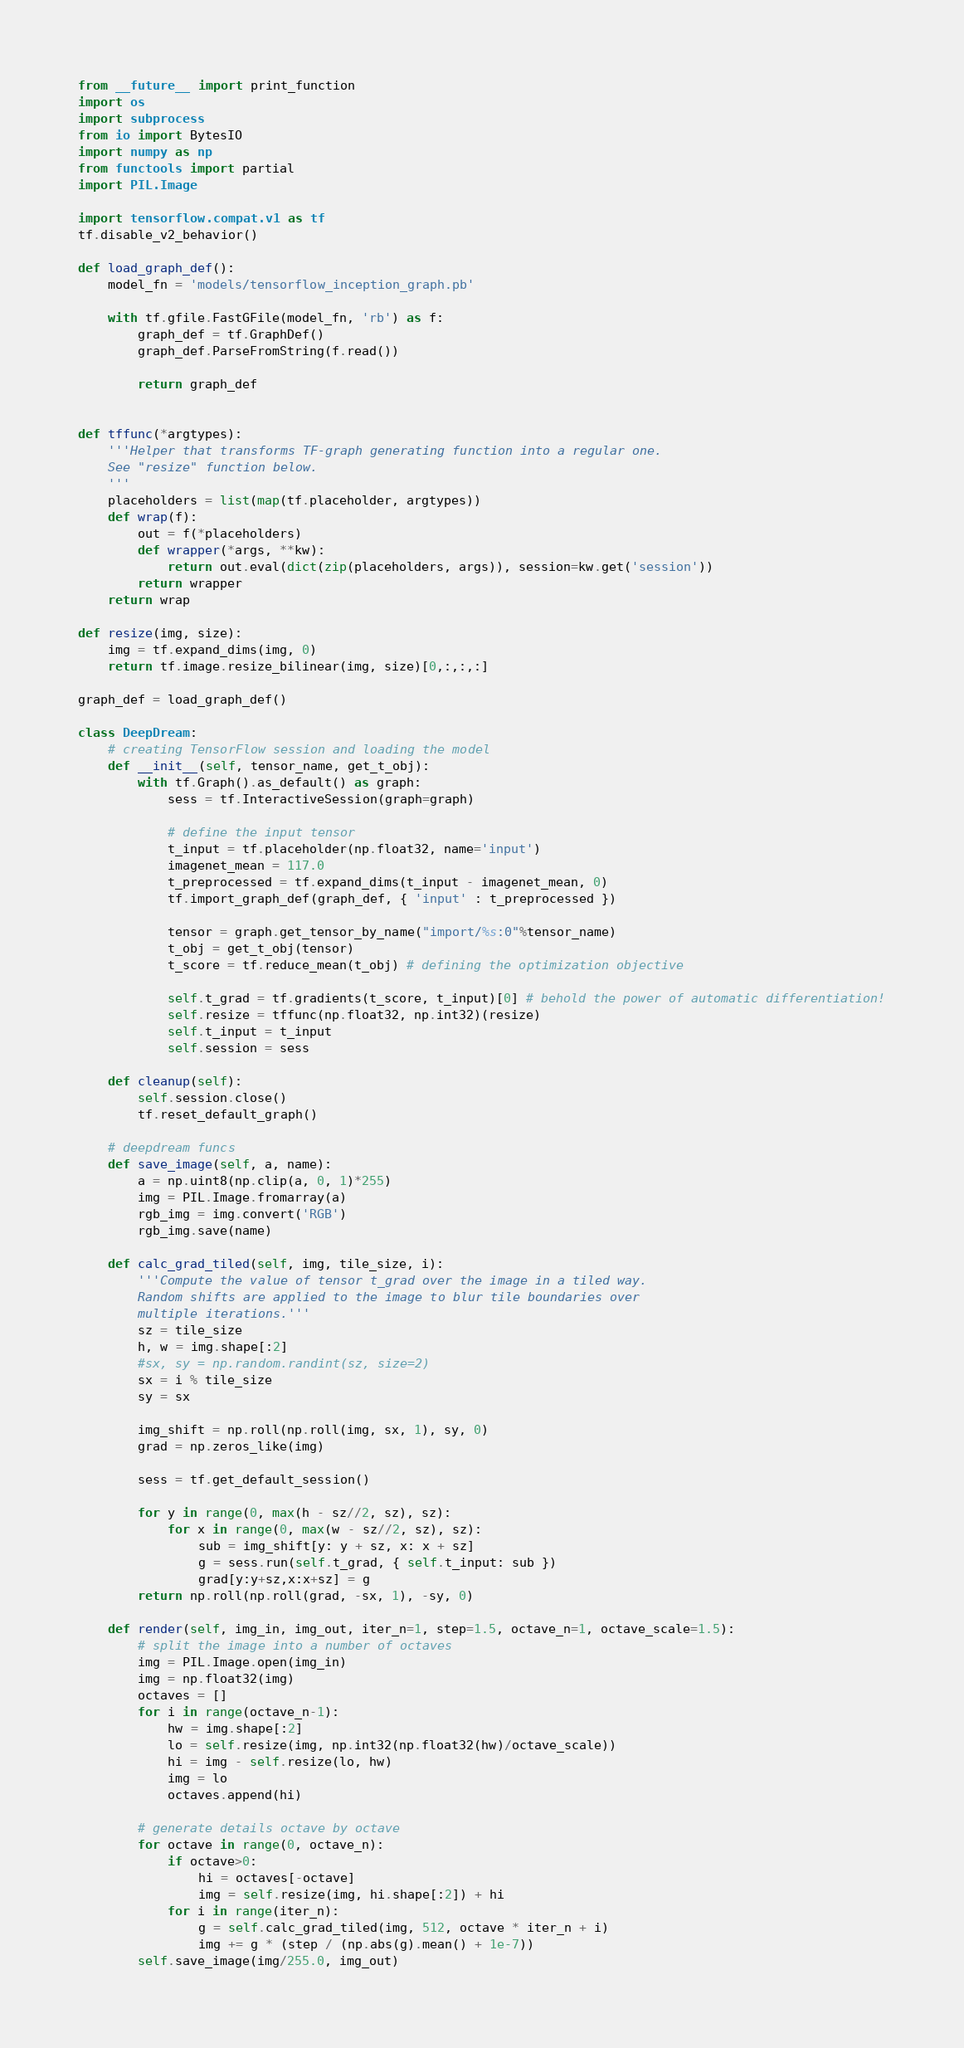Convert code to text. <code><loc_0><loc_0><loc_500><loc_500><_Python_>from __future__ import print_function
import os
import subprocess
from io import BytesIO
import numpy as np
from functools import partial
import PIL.Image

import tensorflow.compat.v1 as tf
tf.disable_v2_behavior()

def load_graph_def():
    model_fn = 'models/tensorflow_inception_graph.pb'

    with tf.gfile.FastGFile(model_fn, 'rb') as f:
        graph_def = tf.GraphDef()
        graph_def.ParseFromString(f.read())

        return graph_def


def tffunc(*argtypes):
    '''Helper that transforms TF-graph generating function into a regular one.
    See "resize" function below.
    '''
    placeholders = list(map(tf.placeholder, argtypes))
    def wrap(f):
        out = f(*placeholders)
        def wrapper(*args, **kw):
            return out.eval(dict(zip(placeholders, args)), session=kw.get('session'))
        return wrapper
    return wrap

def resize(img, size):
    img = tf.expand_dims(img, 0)
    return tf.image.resize_bilinear(img, size)[0,:,:,:]

graph_def = load_graph_def()

class DeepDream:
    # creating TensorFlow session and loading the model
    def __init__(self, tensor_name, get_t_obj):
        with tf.Graph().as_default() as graph:
            sess = tf.InteractiveSession(graph=graph)

            # define the input tensor
            t_input = tf.placeholder(np.float32, name='input')
            imagenet_mean = 117.0
            t_preprocessed = tf.expand_dims(t_input - imagenet_mean, 0)
            tf.import_graph_def(graph_def, { 'input' : t_preprocessed })

            tensor = graph.get_tensor_by_name("import/%s:0"%tensor_name)
            t_obj = get_t_obj(tensor)
            t_score = tf.reduce_mean(t_obj) # defining the optimization objective

            self.t_grad = tf.gradients(t_score, t_input)[0] # behold the power of automatic differentiation!
            self.resize = tffunc(np.float32, np.int32)(resize)
            self.t_input = t_input
            self.session = sess
    
    def cleanup(self):
        self.session.close()
        tf.reset_default_graph()

    # deepdream funcs
    def save_image(self, a, name):
        a = np.uint8(np.clip(a, 0, 1)*255)
        img = PIL.Image.fromarray(a)
        rgb_img = img.convert('RGB')
        rgb_img.save(name)

    def calc_grad_tiled(self, img, tile_size, i):
        '''Compute the value of tensor t_grad over the image in a tiled way.
        Random shifts are applied to the image to blur tile boundaries over 
        multiple iterations.'''
        sz = tile_size
        h, w = img.shape[:2]
        #sx, sy = np.random.randint(sz, size=2)
        sx = i % tile_size
        sy = sx

        img_shift = np.roll(np.roll(img, sx, 1), sy, 0)
        grad = np.zeros_like(img)

        sess = tf.get_default_session()
        
        for y in range(0, max(h - sz//2, sz), sz):
            for x in range(0, max(w - sz//2, sz), sz):
                sub = img_shift[y: y + sz, x: x + sz]
                g = sess.run(self.t_grad, { self.t_input: sub })
                grad[y:y+sz,x:x+sz] = g
        return np.roll(np.roll(grad, -sx, 1), -sy, 0)

    def render(self, img_in, img_out, iter_n=1, step=1.5, octave_n=1, octave_scale=1.5):
        # split the image into a number of octaves
        img = PIL.Image.open(img_in)
        img = np.float32(img)
        octaves = []
        for i in range(octave_n-1):
            hw = img.shape[:2]
            lo = self.resize(img, np.int32(np.float32(hw)/octave_scale))
            hi = img - self.resize(lo, hw)
            img = lo
            octaves.append(hi)
        
        # generate details octave by octave
        for octave in range(0, octave_n):
            if octave>0:
                hi = octaves[-octave]
                img = self.resize(img, hi.shape[:2]) + hi
            for i in range(iter_n):
                g = self.calc_grad_tiled(img, 512, octave * iter_n + i)
                img += g * (step / (np.abs(g).mean() + 1e-7))
        self.save_image(img/255.0, img_out)
</code> 